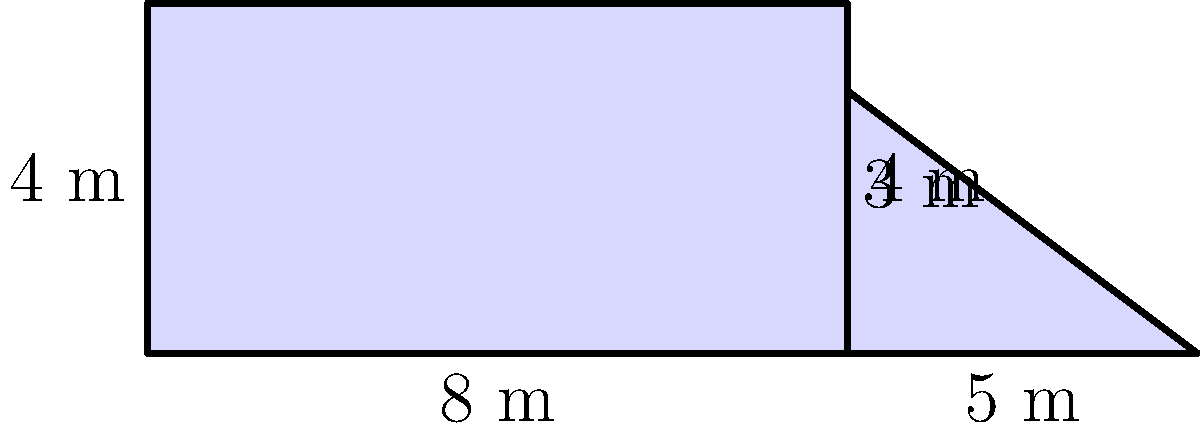As part of an educational event, you're designing a small garden plot for a science experiment. The plot is composed of a rectangular section and a triangular section as shown in the diagram. If the rectangular section is 8 meters long and 4 meters wide, and the triangular section has a base of 5 meters and a height of 3 meters, what is the total area of the garden plot in square meters? To find the total area of the garden plot, we need to calculate the areas of both sections and add them together.

1. Area of the rectangular section:
   $A_{rectangle} = length \times width$
   $A_{rectangle} = 8 \text{ m} \times 4 \text{ m} = 32 \text{ m}^2$

2. Area of the triangular section:
   $A_{triangle} = \frac{1}{2} \times base \times height$
   $A_{triangle} = \frac{1}{2} \times 5 \text{ m} \times 3 \text{ m} = 7.5 \text{ m}^2$

3. Total area of the garden plot:
   $A_{total} = A_{rectangle} + A_{triangle}$
   $A_{total} = 32 \text{ m}^2 + 7.5 \text{ m}^2 = 39.5 \text{ m}^2$

Therefore, the total area of the garden plot is 39.5 square meters.
Answer: 39.5 m² 